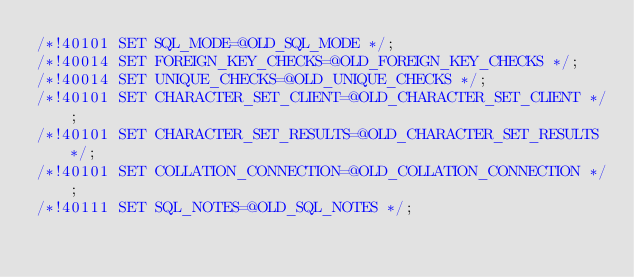<code> <loc_0><loc_0><loc_500><loc_500><_SQL_>/*!40101 SET SQL_MODE=@OLD_SQL_MODE */;
/*!40014 SET FOREIGN_KEY_CHECKS=@OLD_FOREIGN_KEY_CHECKS */;
/*!40014 SET UNIQUE_CHECKS=@OLD_UNIQUE_CHECKS */;
/*!40101 SET CHARACTER_SET_CLIENT=@OLD_CHARACTER_SET_CLIENT */;
/*!40101 SET CHARACTER_SET_RESULTS=@OLD_CHARACTER_SET_RESULTS */;
/*!40101 SET COLLATION_CONNECTION=@OLD_COLLATION_CONNECTION */;
/*!40111 SET SQL_NOTES=@OLD_SQL_NOTES */;

</code> 